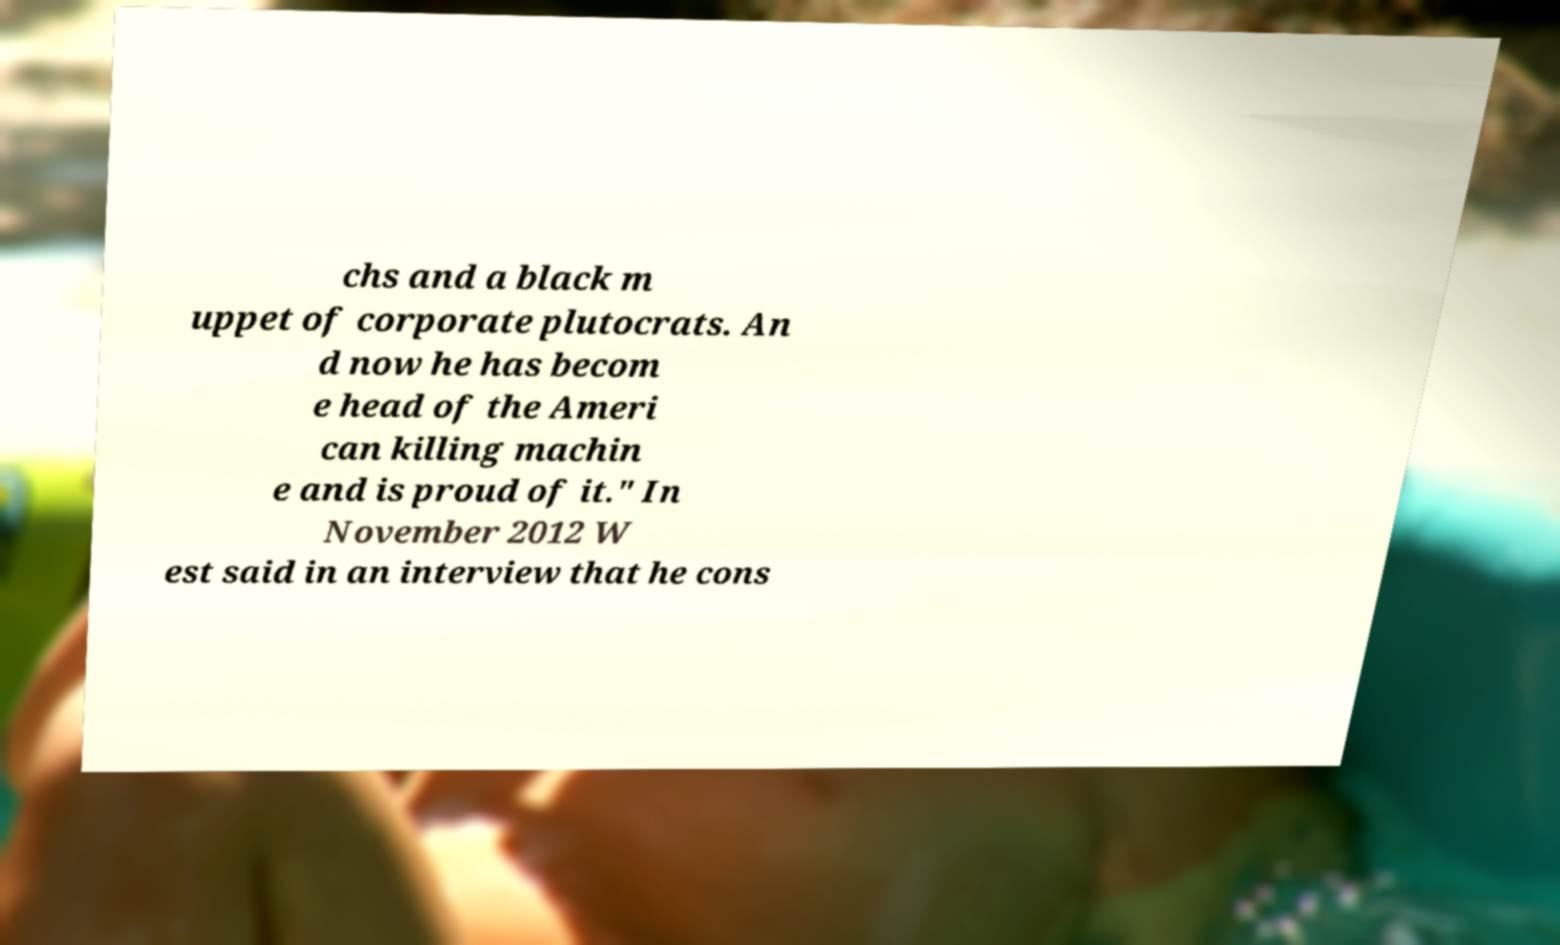Can you accurately transcribe the text from the provided image for me? chs and a black m uppet of corporate plutocrats. An d now he has becom e head of the Ameri can killing machin e and is proud of it." In November 2012 W est said in an interview that he cons 